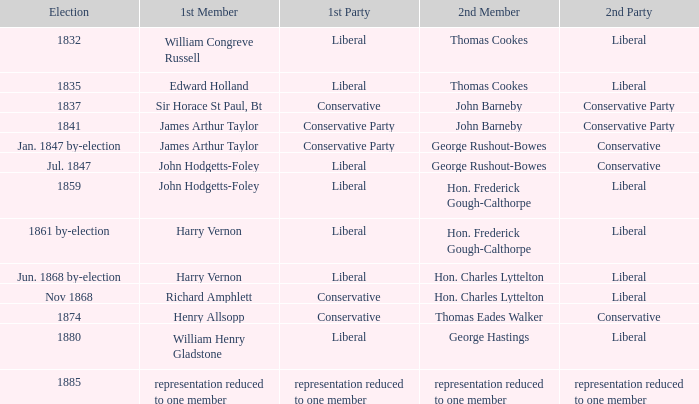If the 1st party is conservative, identify the 2nd party that had john barneby as its 2nd member. Conservative Party. Write the full table. {'header': ['Election', '1st Member', '1st Party', '2nd Member', '2nd Party'], 'rows': [['1832', 'William Congreve Russell', 'Liberal', 'Thomas Cookes', 'Liberal'], ['1835', 'Edward Holland', 'Liberal', 'Thomas Cookes', 'Liberal'], ['1837', 'Sir Horace St Paul, Bt', 'Conservative', 'John Barneby', 'Conservative Party'], ['1841', 'James Arthur Taylor', 'Conservative Party', 'John Barneby', 'Conservative Party'], ['Jan. 1847 by-election', 'James Arthur Taylor', 'Conservative Party', 'George Rushout-Bowes', 'Conservative'], ['Jul. 1847', 'John Hodgetts-Foley', 'Liberal', 'George Rushout-Bowes', 'Conservative'], ['1859', 'John Hodgetts-Foley', 'Liberal', 'Hon. Frederick Gough-Calthorpe', 'Liberal'], ['1861 by-election', 'Harry Vernon', 'Liberal', 'Hon. Frederick Gough-Calthorpe', 'Liberal'], ['Jun. 1868 by-election', 'Harry Vernon', 'Liberal', 'Hon. Charles Lyttelton', 'Liberal'], ['Nov 1868', 'Richard Amphlett', 'Conservative', 'Hon. Charles Lyttelton', 'Liberal'], ['1874', 'Henry Allsopp', 'Conservative', 'Thomas Eades Walker', 'Conservative'], ['1880', 'William Henry Gladstone', 'Liberal', 'George Hastings', 'Liberal'], ['1885', 'representation reduced to one member', 'representation reduced to one member', 'representation reduced to one member', 'representation reduced to one member']]} 